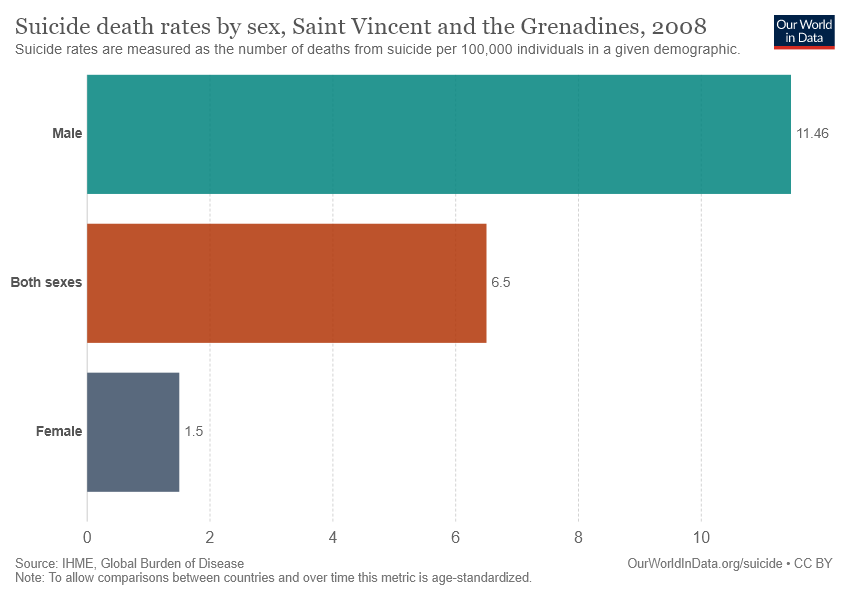Specify some key components in this picture. The suicide death rate for both sexes is 6.5 per 100,000 population. The average between male and female is approximately 0.0648. 